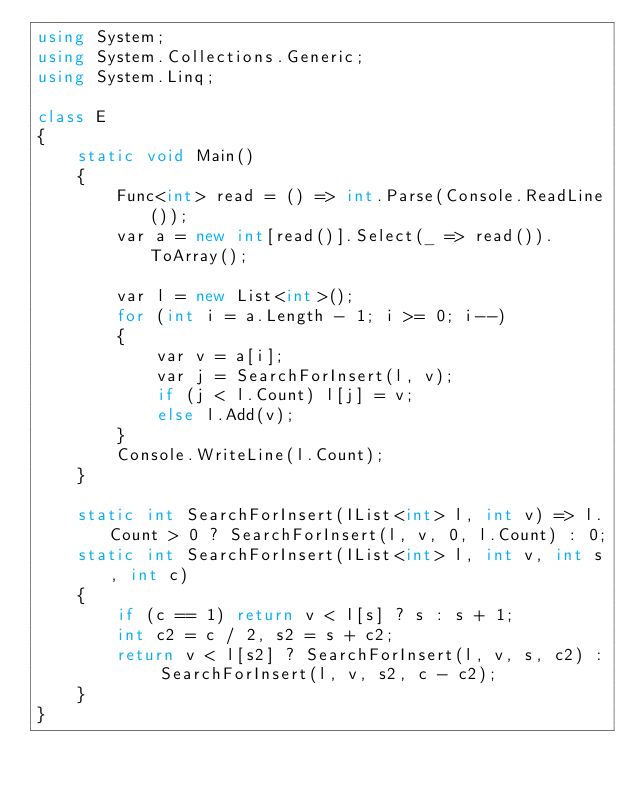Convert code to text. <code><loc_0><loc_0><loc_500><loc_500><_C#_>using System;
using System.Collections.Generic;
using System.Linq;

class E
{
	static void Main()
	{
		Func<int> read = () => int.Parse(Console.ReadLine());
		var a = new int[read()].Select(_ => read()).ToArray();

		var l = new List<int>();
		for (int i = a.Length - 1; i >= 0; i--)
		{
			var v = a[i];
			var j = SearchForInsert(l, v);
			if (j < l.Count) l[j] = v;
			else l.Add(v);
		}
		Console.WriteLine(l.Count);
	}

	static int SearchForInsert(IList<int> l, int v) => l.Count > 0 ? SearchForInsert(l, v, 0, l.Count) : 0;
	static int SearchForInsert(IList<int> l, int v, int s, int c)
	{
		if (c == 1) return v < l[s] ? s : s + 1;
		int c2 = c / 2, s2 = s + c2;
		return v < l[s2] ? SearchForInsert(l, v, s, c2) : SearchForInsert(l, v, s2, c - c2);
	}
}
</code> 